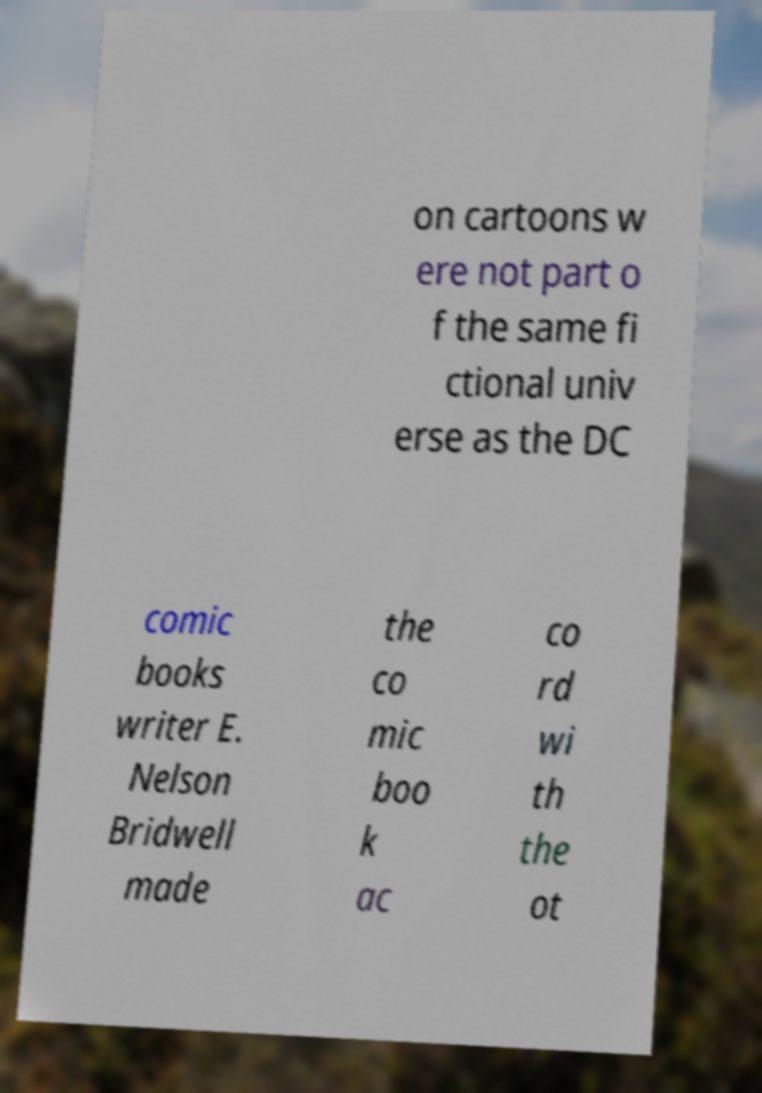For documentation purposes, I need the text within this image transcribed. Could you provide that? on cartoons w ere not part o f the same fi ctional univ erse as the DC comic books writer E. Nelson Bridwell made the co mic boo k ac co rd wi th the ot 